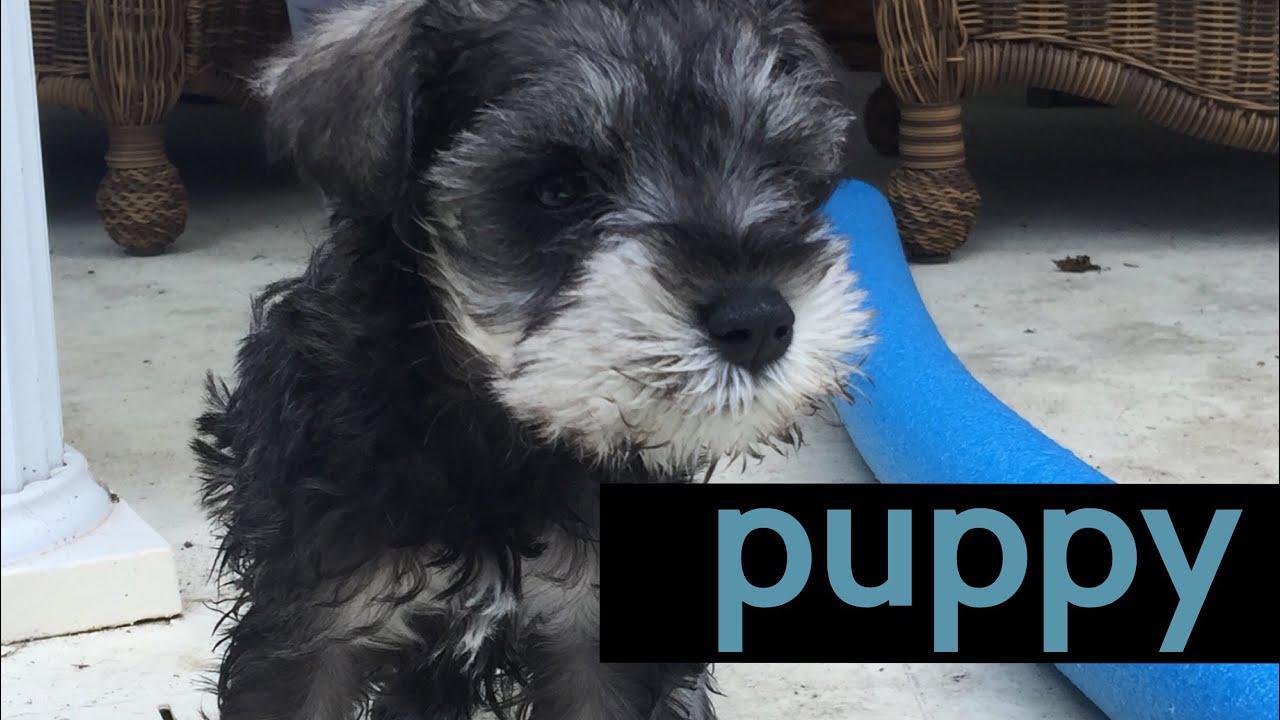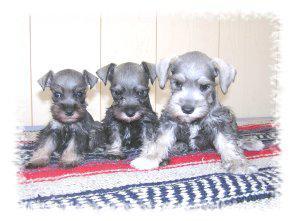The first image is the image on the left, the second image is the image on the right. Given the left and right images, does the statement "there is three dogs in the right side image" hold true? Answer yes or no. Yes. The first image is the image on the left, the second image is the image on the right. For the images shown, is this caption "There are exactly four dogs." true? Answer yes or no. Yes. 